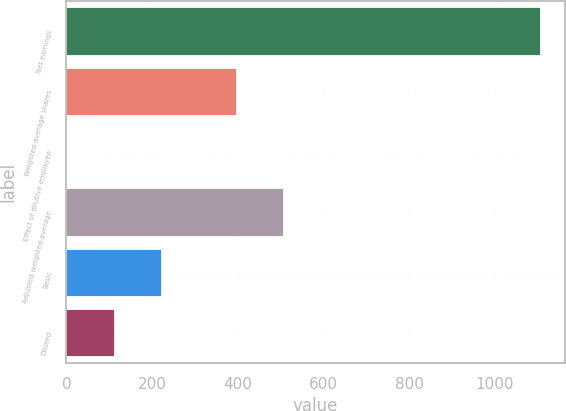<chart> <loc_0><loc_0><loc_500><loc_500><bar_chart><fcel>Net earnings<fcel>Weighted-average shares<fcel>Effect of dilutive employee<fcel>Adjusted weighted-average<fcel>Basic<fcel>Diluted<nl><fcel>1107.4<fcel>397.4<fcel>2<fcel>507.94<fcel>223.08<fcel>112.54<nl></chart> 